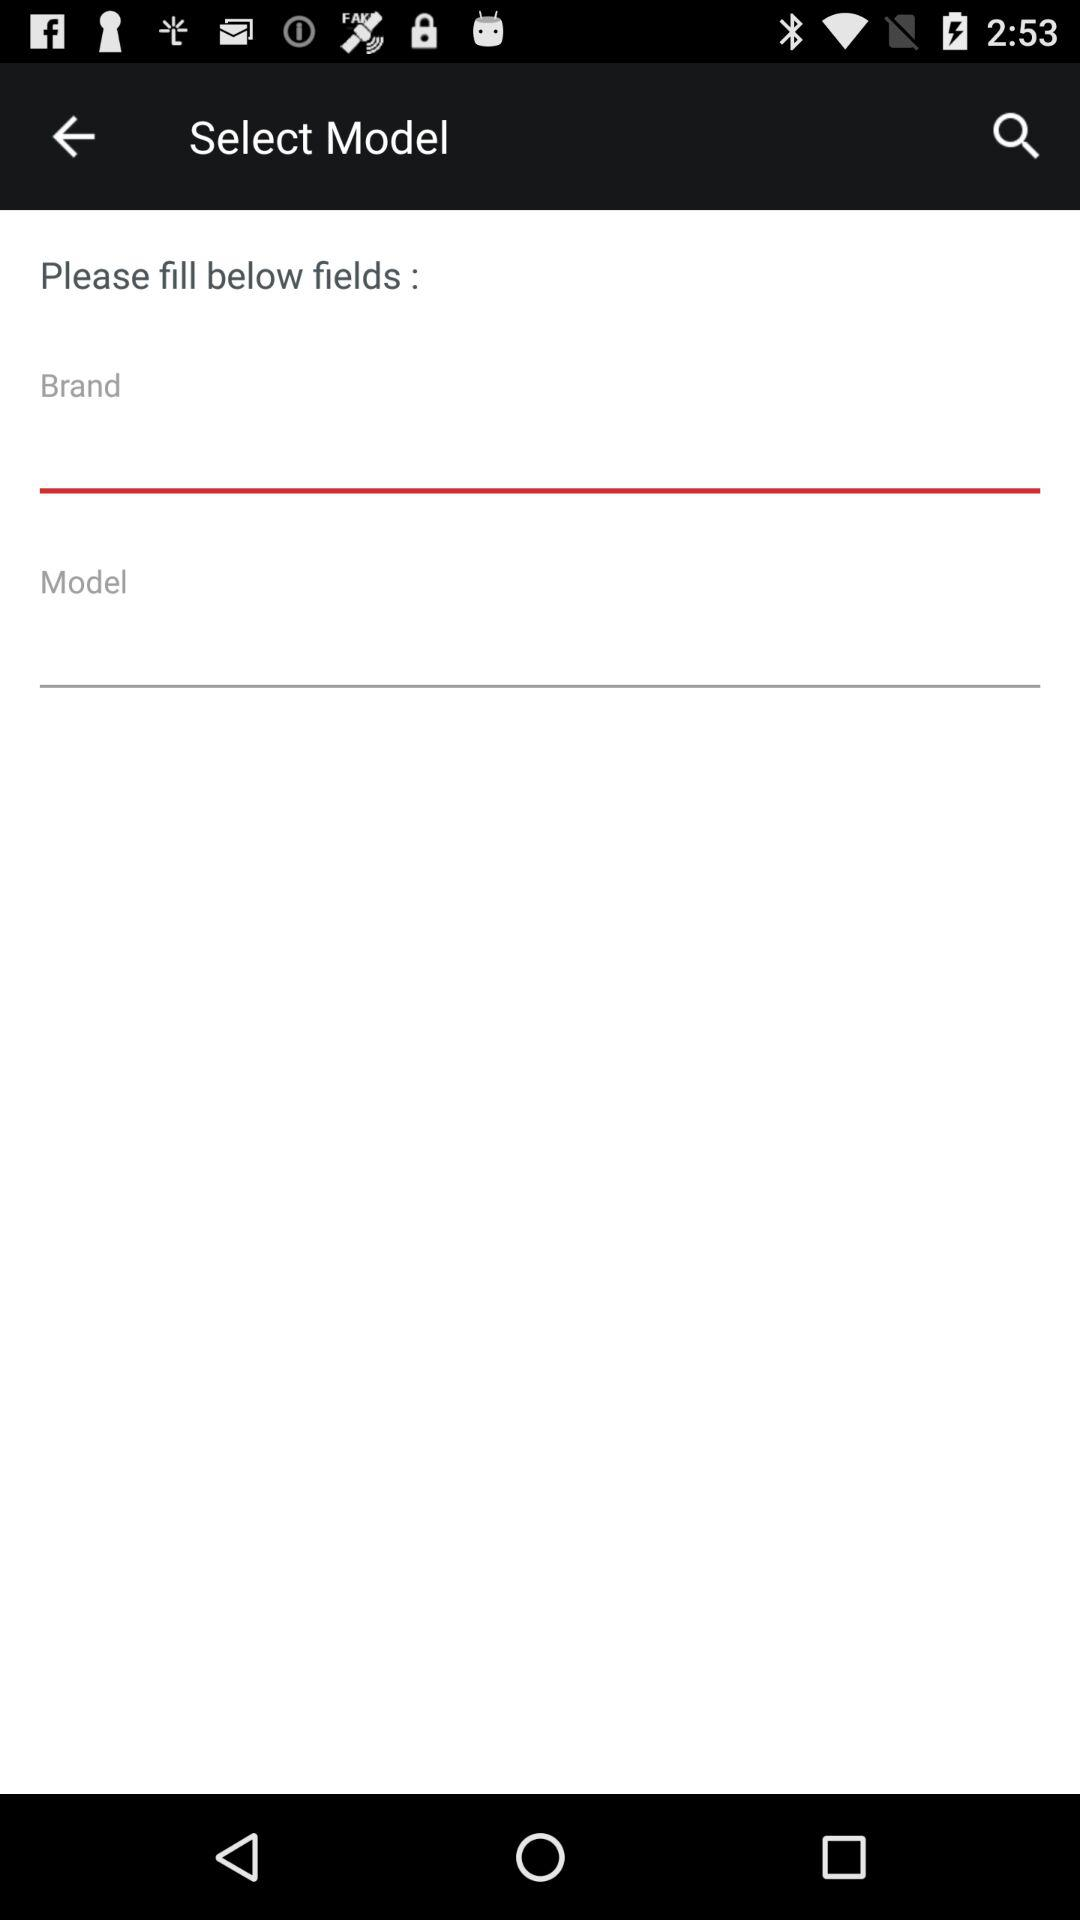How many fields are there for the user to fill out?
Answer the question using a single word or phrase. 2 